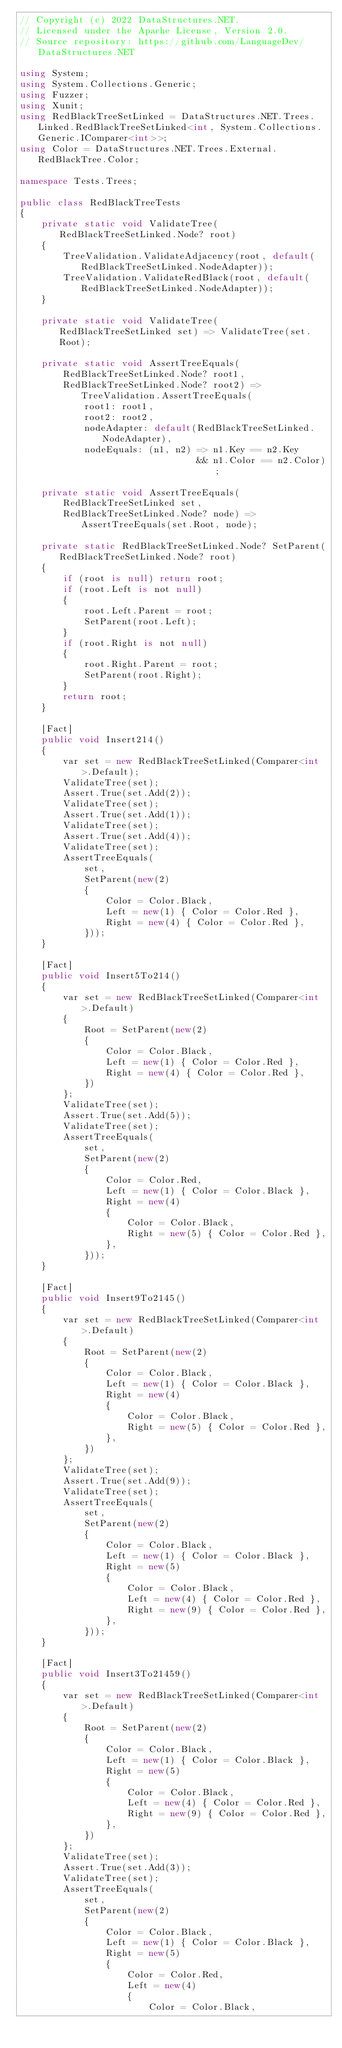<code> <loc_0><loc_0><loc_500><loc_500><_C#_>// Copyright (c) 2022 DataStructures.NET.
// Licensed under the Apache License, Version 2.0.
// Source repository: https://github.com/LanguageDev/DataStructures.NET

using System;
using System.Collections.Generic;
using Fuzzer;
using Xunit;
using RedBlackTreeSetLinked = DataStructures.NET.Trees.Linked.RedBlackTreeSetLinked<int, System.Collections.Generic.IComparer<int>>;
using Color = DataStructures.NET.Trees.External.RedBlackTree.Color;

namespace Tests.Trees;

public class RedBlackTreeTests
{
    private static void ValidateTree(RedBlackTreeSetLinked.Node? root)
    {
        TreeValidation.ValidateAdjacency(root, default(RedBlackTreeSetLinked.NodeAdapter));
        TreeValidation.ValidateRedBlack(root, default(RedBlackTreeSetLinked.NodeAdapter));
    }

    private static void ValidateTree(RedBlackTreeSetLinked set) => ValidateTree(set.Root);

    private static void AssertTreeEquals(
        RedBlackTreeSetLinked.Node? root1,
        RedBlackTreeSetLinked.Node? root2) => TreeValidation.AssertTreeEquals(
            root1: root1,
            root2: root2,
            nodeAdapter: default(RedBlackTreeSetLinked.NodeAdapter),
            nodeEquals: (n1, n2) => n1.Key == n2.Key
                                 && n1.Color == n2.Color);

    private static void AssertTreeEquals(
        RedBlackTreeSetLinked set,
        RedBlackTreeSetLinked.Node? node) => AssertTreeEquals(set.Root, node);

    private static RedBlackTreeSetLinked.Node? SetParent(RedBlackTreeSetLinked.Node? root)
    {
        if (root is null) return root;
        if (root.Left is not null)
        {
            root.Left.Parent = root;
            SetParent(root.Left);
        }
        if (root.Right is not null)
        {
            root.Right.Parent = root;
            SetParent(root.Right);
        }
        return root;
    }

    [Fact]
    public void Insert214()
    {
        var set = new RedBlackTreeSetLinked(Comparer<int>.Default);
        ValidateTree(set);
        Assert.True(set.Add(2));
        ValidateTree(set);
        Assert.True(set.Add(1));
        ValidateTree(set);
        Assert.True(set.Add(4));
        ValidateTree(set);
        AssertTreeEquals(
            set,
            SetParent(new(2)
            {
                Color = Color.Black,
                Left = new(1) { Color = Color.Red },
                Right = new(4) { Color = Color.Red },
            }));
    }

    [Fact]
    public void Insert5To214()
    {
        var set = new RedBlackTreeSetLinked(Comparer<int>.Default)
        {
            Root = SetParent(new(2)
            {
                Color = Color.Black,
                Left = new(1) { Color = Color.Red },
                Right = new(4) { Color = Color.Red },
            })
        };
        ValidateTree(set);
        Assert.True(set.Add(5));
        ValidateTree(set);
        AssertTreeEquals(
            set,
            SetParent(new(2)
            {
                Color = Color.Red,
                Left = new(1) { Color = Color.Black },
                Right = new(4)
                {
                    Color = Color.Black,
                    Right = new(5) { Color = Color.Red },
                },
            }));
    }

    [Fact]
    public void Insert9To2145()
    {
        var set = new RedBlackTreeSetLinked(Comparer<int>.Default)
        {
            Root = SetParent(new(2)
            {
                Color = Color.Black,
                Left = new(1) { Color = Color.Black },
                Right = new(4)
                {
                    Color = Color.Black,
                    Right = new(5) { Color = Color.Red },
                },
            })
        };
        ValidateTree(set);
        Assert.True(set.Add(9));
        ValidateTree(set);
        AssertTreeEquals(
            set,
            SetParent(new(2)
            {
                Color = Color.Black,
                Left = new(1) { Color = Color.Black },
                Right = new(5)
                {
                    Color = Color.Black,
                    Left = new(4) { Color = Color.Red },
                    Right = new(9) { Color = Color.Red },
                },
            }));
    }

    [Fact]
    public void Insert3To21459()
    {
        var set = new RedBlackTreeSetLinked(Comparer<int>.Default)
        {
            Root = SetParent(new(2)
            {
                Color = Color.Black,
                Left = new(1) { Color = Color.Black },
                Right = new(5)
                {
                    Color = Color.Black,
                    Left = new(4) { Color = Color.Red },
                    Right = new(9) { Color = Color.Red },
                },
            })
        };
        ValidateTree(set);
        Assert.True(set.Add(3));
        ValidateTree(set);
        AssertTreeEquals(
            set,
            SetParent(new(2)
            {
                Color = Color.Black,
                Left = new(1) { Color = Color.Black },
                Right = new(5)
                {
                    Color = Color.Red,
                    Left = new(4)
                    {
                        Color = Color.Black,</code> 